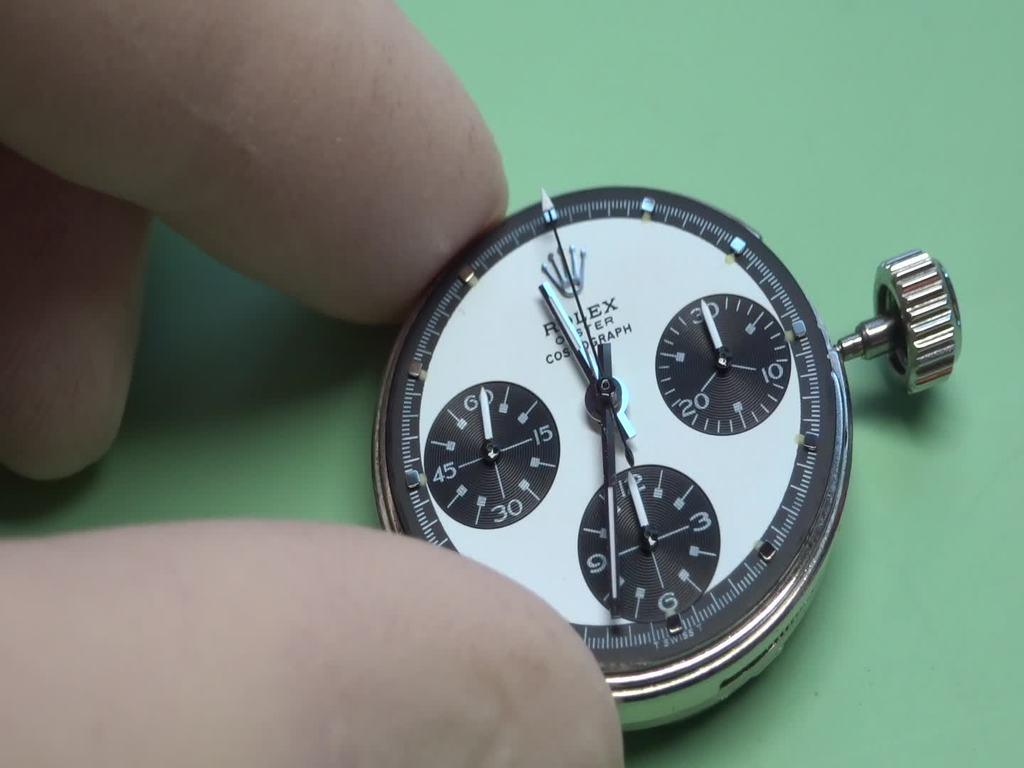<image>
Give a short and clear explanation of the subsequent image. A Rolex stop watch on a green table held by a human hand. 